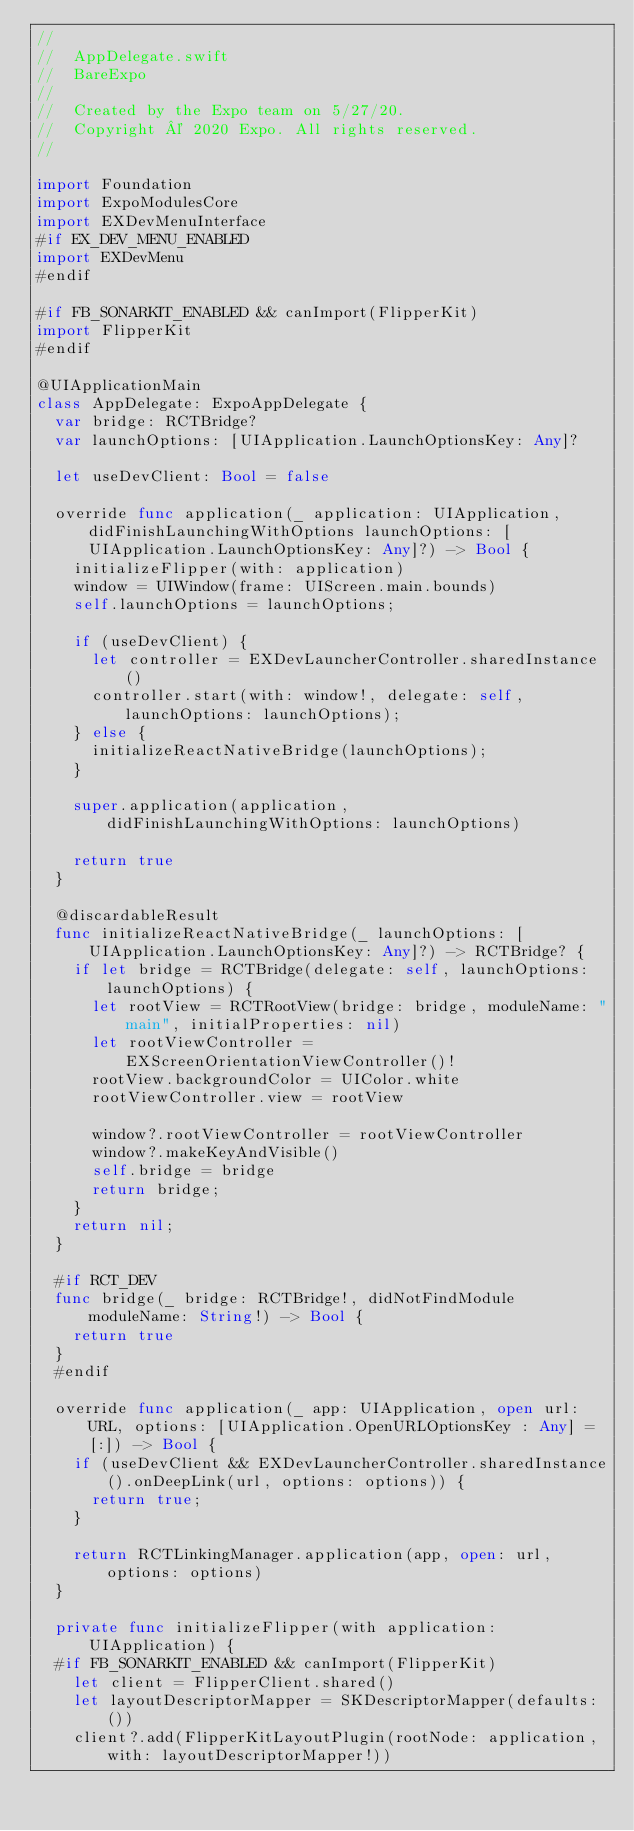<code> <loc_0><loc_0><loc_500><loc_500><_Swift_>//
//  AppDelegate.swift
//  BareExpo
//
//  Created by the Expo team on 5/27/20.
//  Copyright © 2020 Expo. All rights reserved.
//

import Foundation
import ExpoModulesCore
import EXDevMenuInterface
#if EX_DEV_MENU_ENABLED
import EXDevMenu
#endif

#if FB_SONARKIT_ENABLED && canImport(FlipperKit)
import FlipperKit
#endif

@UIApplicationMain
class AppDelegate: ExpoAppDelegate {
  var bridge: RCTBridge?
  var launchOptions: [UIApplication.LaunchOptionsKey: Any]?

  let useDevClient: Bool = false
  
  override func application(_ application: UIApplication, didFinishLaunchingWithOptions launchOptions: [UIApplication.LaunchOptionsKey: Any]?) -> Bool {
    initializeFlipper(with: application)
    window = UIWindow(frame: UIScreen.main.bounds)
    self.launchOptions = launchOptions;

    if (useDevClient) {
      let controller = EXDevLauncherController.sharedInstance()
      controller.start(with: window!, delegate: self, launchOptions: launchOptions);
    } else {
      initializeReactNativeBridge(launchOptions);
    }

    super.application(application, didFinishLaunchingWithOptions: launchOptions)
    
    return true
  }

  @discardableResult
  func initializeReactNativeBridge(_ launchOptions: [UIApplication.LaunchOptionsKey: Any]?) -> RCTBridge? {
    if let bridge = RCTBridge(delegate: self, launchOptions: launchOptions) {
      let rootView = RCTRootView(bridge: bridge, moduleName: "main", initialProperties: nil)
      let rootViewController = EXScreenOrientationViewController()!
      rootView.backgroundColor = UIColor.white
      rootViewController.view = rootView

      window?.rootViewController = rootViewController
      window?.makeKeyAndVisible()
      self.bridge = bridge
      return bridge;
    }
    return nil;
  }
  
  #if RCT_DEV
  func bridge(_ bridge: RCTBridge!, didNotFindModule moduleName: String!) -> Bool {
    return true
  }
  #endif
  
  override func application(_ app: UIApplication, open url: URL, options: [UIApplication.OpenURLOptionsKey : Any] = [:]) -> Bool {
    if (useDevClient && EXDevLauncherController.sharedInstance().onDeepLink(url, options: options)) {
      return true;
    }
    
    return RCTLinkingManager.application(app, open: url, options: options)
  }
  
  private func initializeFlipper(with application: UIApplication) {
  #if FB_SONARKIT_ENABLED && canImport(FlipperKit)
    let client = FlipperClient.shared()
    let layoutDescriptorMapper = SKDescriptorMapper(defaults: ())
    client?.add(FlipperKitLayoutPlugin(rootNode: application, with: layoutDescriptorMapper!))</code> 